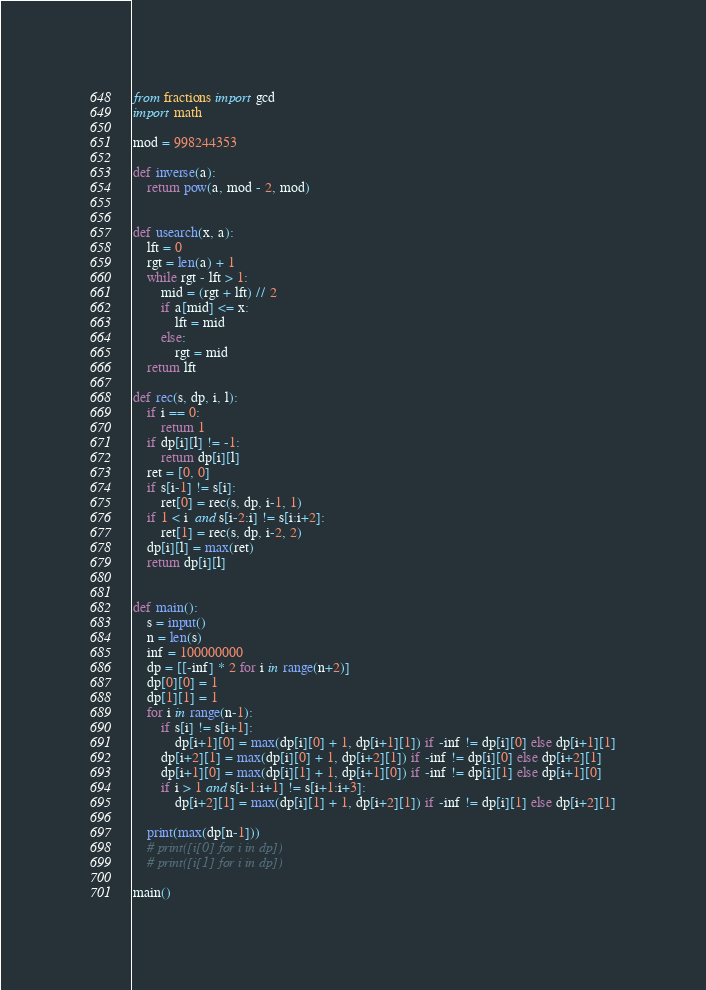<code> <loc_0><loc_0><loc_500><loc_500><_Python_>from fractions import gcd
import math

mod = 998244353

def inverse(a):
    return pow(a, mod - 2, mod)


def usearch(x, a):
    lft = 0
    rgt = len(a) + 1
    while rgt - lft > 1:
        mid = (rgt + lft) // 2
        if a[mid] <= x:
            lft = mid
        else:
            rgt = mid
    return lft

def rec(s, dp, i, l):
    if i == 0:
        return 1
    if dp[i][l] != -1:
        return dp[i][l]
    ret = [0, 0]
    if s[i-1] != s[i]:
        ret[0] = rec(s, dp, i-1, 1)
    if 1 < i  and s[i-2:i] != s[i:i+2]:
        ret[1] = rec(s, dp, i-2, 2)
    dp[i][l] = max(ret)
    return dp[i][l]


def main():
    s = input()
    n = len(s)
    inf = 100000000
    dp = [[-inf] * 2 for i in range(n+2)]
    dp[0][0] = 1
    dp[1][1] = 1
    for i in range(n-1):
        if s[i] != s[i+1]:
            dp[i+1][0] = max(dp[i][0] + 1, dp[i+1][1]) if -inf != dp[i][0] else dp[i+1][1]
        dp[i+2][1] = max(dp[i][0] + 1, dp[i+2][1]) if -inf != dp[i][0] else dp[i+2][1]
        dp[i+1][0] = max(dp[i][1] + 1, dp[i+1][0]) if -inf != dp[i][1] else dp[i+1][0]
        if i > 1 and s[i-1:i+1] != s[i+1:i+3]:
            dp[i+2][1] = max(dp[i][1] + 1, dp[i+2][1]) if -inf != dp[i][1] else dp[i+2][1]

    print(max(dp[n-1]))
    # print([i[0] for i in dp])
    # print([i[1] for i in dp])

main()
</code> 